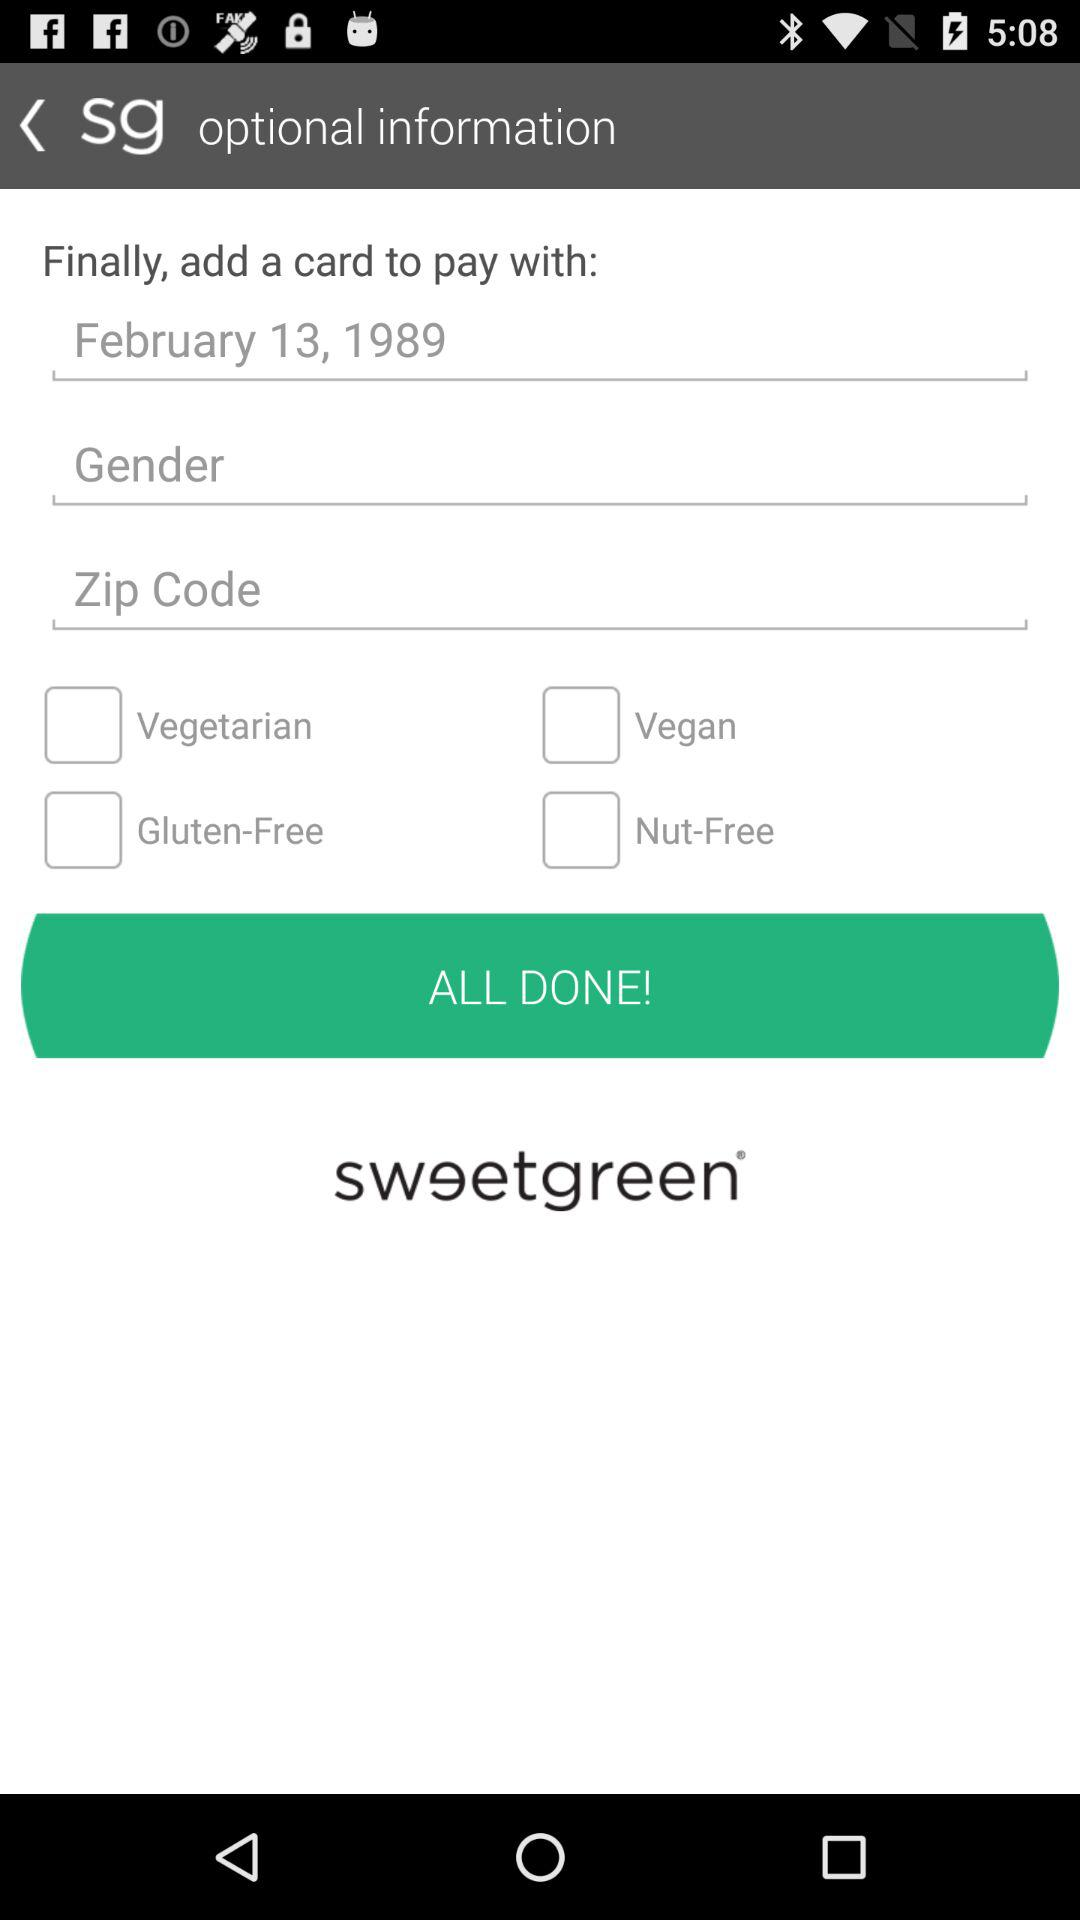How many check boxes are there in total?
Answer the question using a single word or phrase. 4 